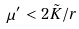Convert formula to latex. <formula><loc_0><loc_0><loc_500><loc_500>\mu ^ { \prime } < 2 \tilde { K } / r</formula> 